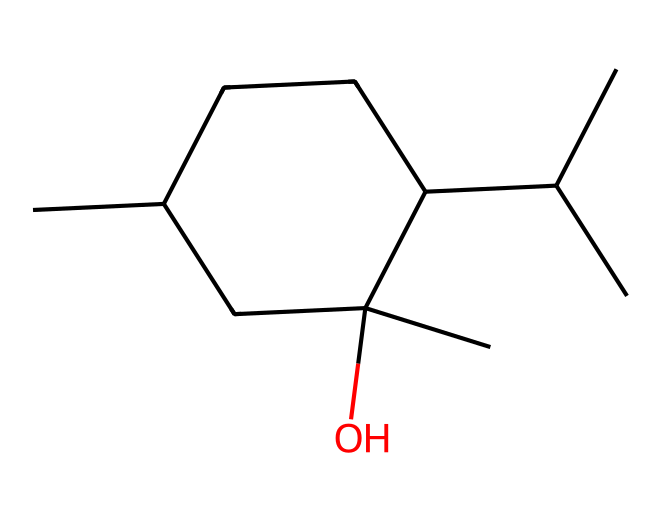What is the name of this chemical? The provided SMILES representation corresponds to the structure of menthol, which is a cyclic compound derived from peppermint.
Answer: menthol How many carbon atoms are present in menthol? By analyzing the SMILES, we can count the total number of carbon atoms represented; in this case, there are 10 carbon atoms in menthol's structure.
Answer: 10 How many hydroxyl (-OH) groups does menthol contain? Looking closely at the SMILES representation, we see that there is one hydroxyl group in the structure (as indicated by the ‘O’ in the code) attached to a carbon.
Answer: 1 Is menthol a cyclic compound? The structure indicates a closed ring formation (indicated by the 'C1' and 'C1' notation in SMILES), confirming that it is indeed a cyclic compound.
Answer: yes What type of chemical bonding is primarily present in menthol? The structure mainly consists of carbon-carbon (C-C) and carbon-hydrogen (C-H) bonds as characteristic of aliphatic compounds, which are prevalent in menthol.
Answer: carbon-carbon and carbon-hydrogen bonds What is the functional group present in menthol responsible for its calming effects? The hydroxyl (-OH) functional group is present in menthol, which is responsible for its therapeutic and calming properties.
Answer: hydroxyl group How does the cyclic nature of menthol affect its boiling point compared to straight-chain alkanes? The cyclic structure of menthol creates steric hindrance and intramolecular interactions, which typically result in a higher boiling point than that of straight-chain alkanes with a similar number of carbon atoms.
Answer: higher boiling point 